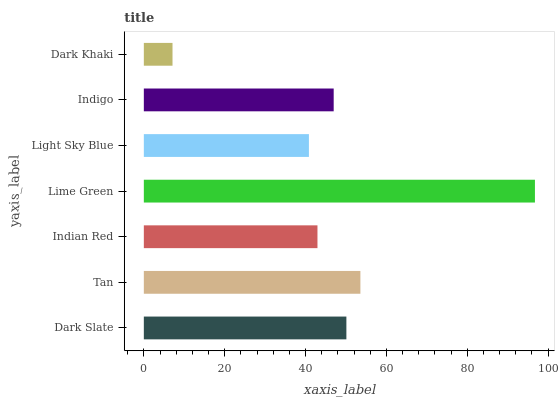Is Dark Khaki the minimum?
Answer yes or no. Yes. Is Lime Green the maximum?
Answer yes or no. Yes. Is Tan the minimum?
Answer yes or no. No. Is Tan the maximum?
Answer yes or no. No. Is Tan greater than Dark Slate?
Answer yes or no. Yes. Is Dark Slate less than Tan?
Answer yes or no. Yes. Is Dark Slate greater than Tan?
Answer yes or no. No. Is Tan less than Dark Slate?
Answer yes or no. No. Is Indigo the high median?
Answer yes or no. Yes. Is Indigo the low median?
Answer yes or no. Yes. Is Dark Khaki the high median?
Answer yes or no. No. Is Dark Khaki the low median?
Answer yes or no. No. 